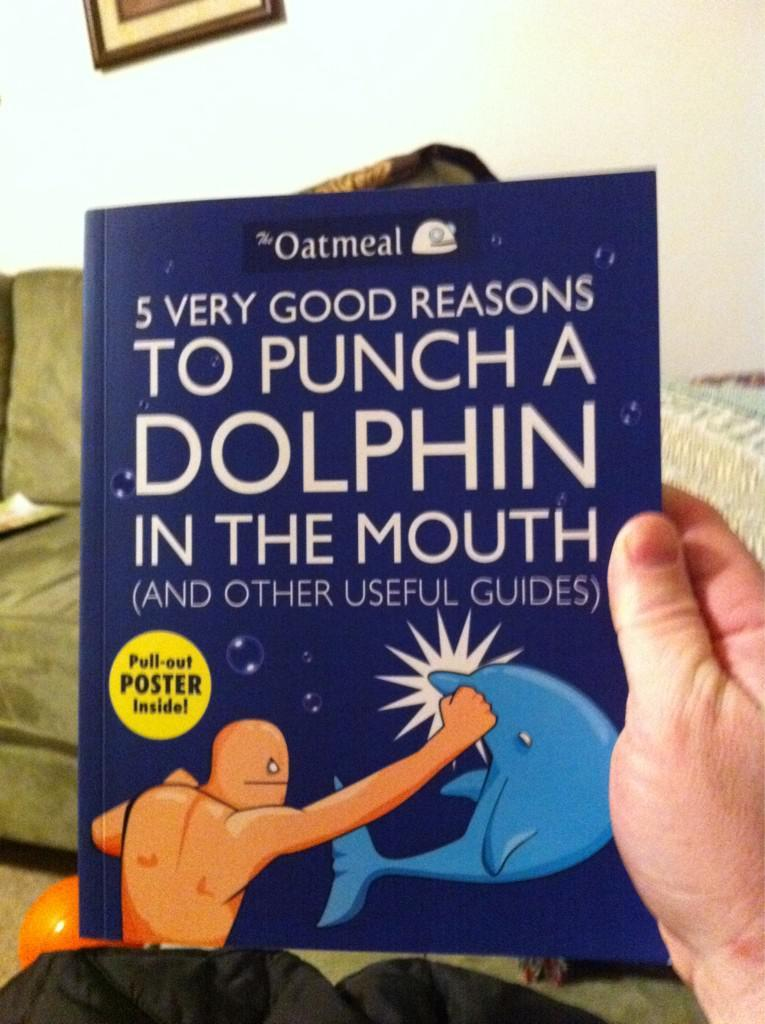What is being held by the hand in the image? There is a book held with a hand in the image. What type of material is visible in the image? There is cloth visible in the image. What else can be seen in the image besides the book and cloth? There are objects in the image. What is located on the wall in the background of the image? There is a frame on the wall in the background of the image. What type of operation is being performed on the book in the image? There is no operation being performed on the book in the image; it is simply being held by a hand. 